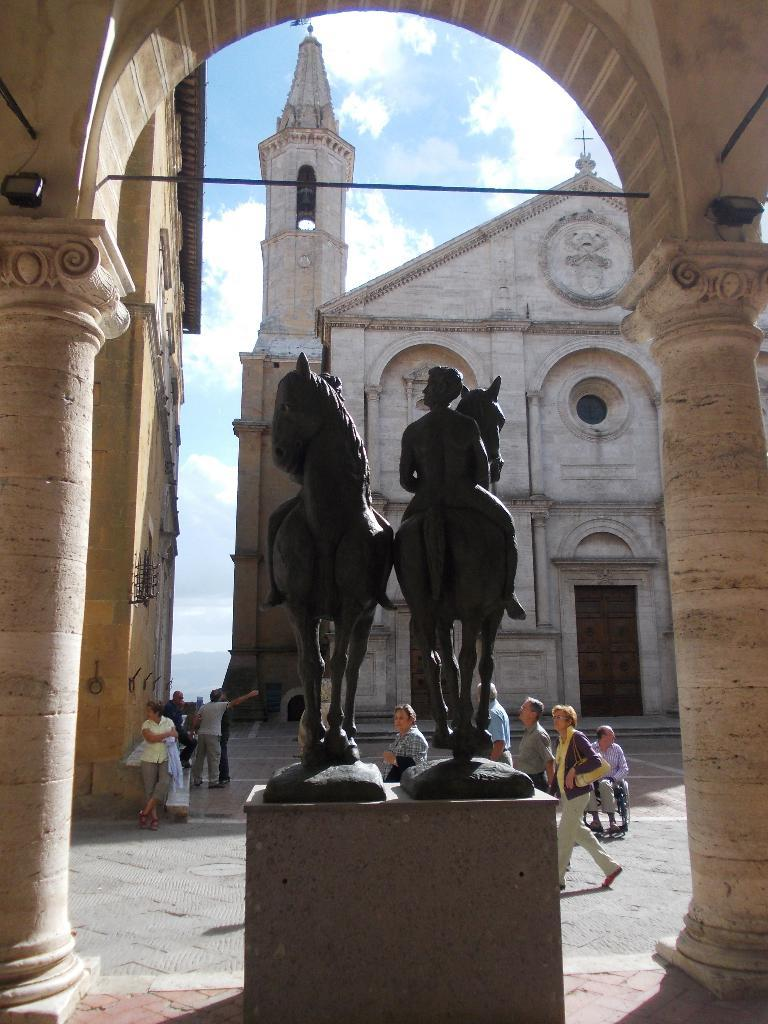What is the main subject of the image? There is a black color statue in the image. What else can be seen in the image besides the statue? There are people walking in the image, and there is a building in the background. Can you describe the building in the background? The building is in cream color. What is visible in the sky in the image? The sky has a combination of white and blue colors. Who is the manager of the house in the image? There is no house present in the image, only a statue, people walking, a building, and the sky. Can you tell me how many suns are visible in the image? There is no sun visible in the image; only the sky with a combination of white and blue colors is present. 